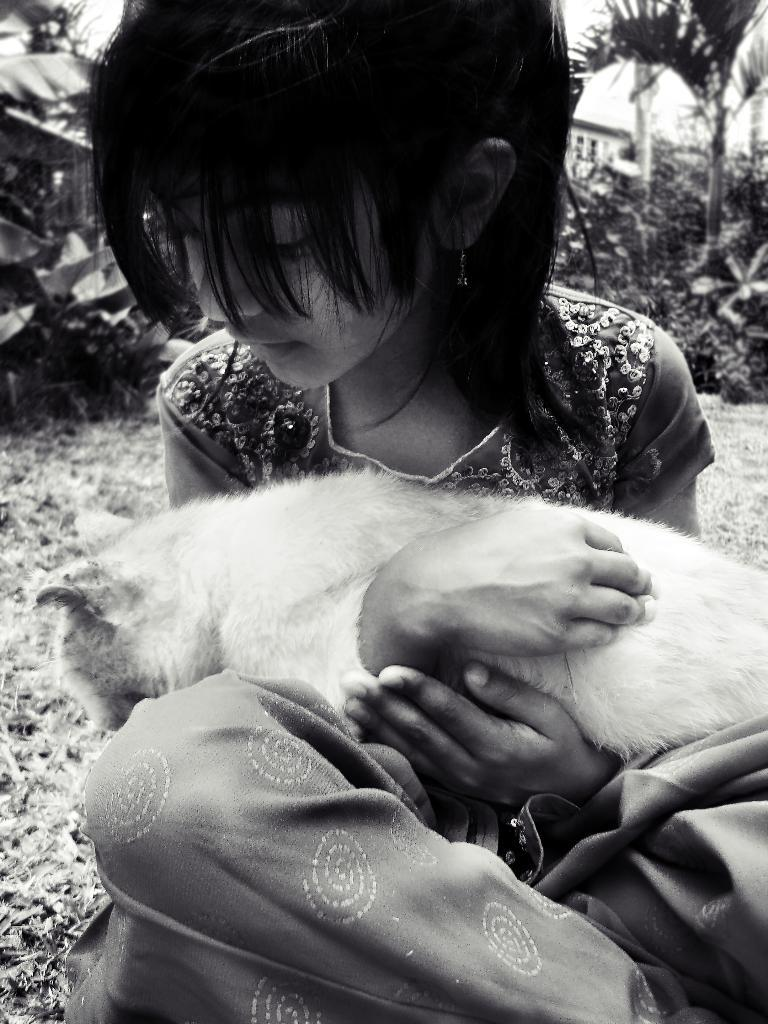Who is the main subject in the image? There is a girl in the image. What is the girl holding in the image? The girl is holding an animal. What type of jewel is the girl wearing on her nose in the image? There is no jewel visible on the girl's nose in the image. What time is indicated on the watch the girl is wearing in the image? There is no watch present in the image. 